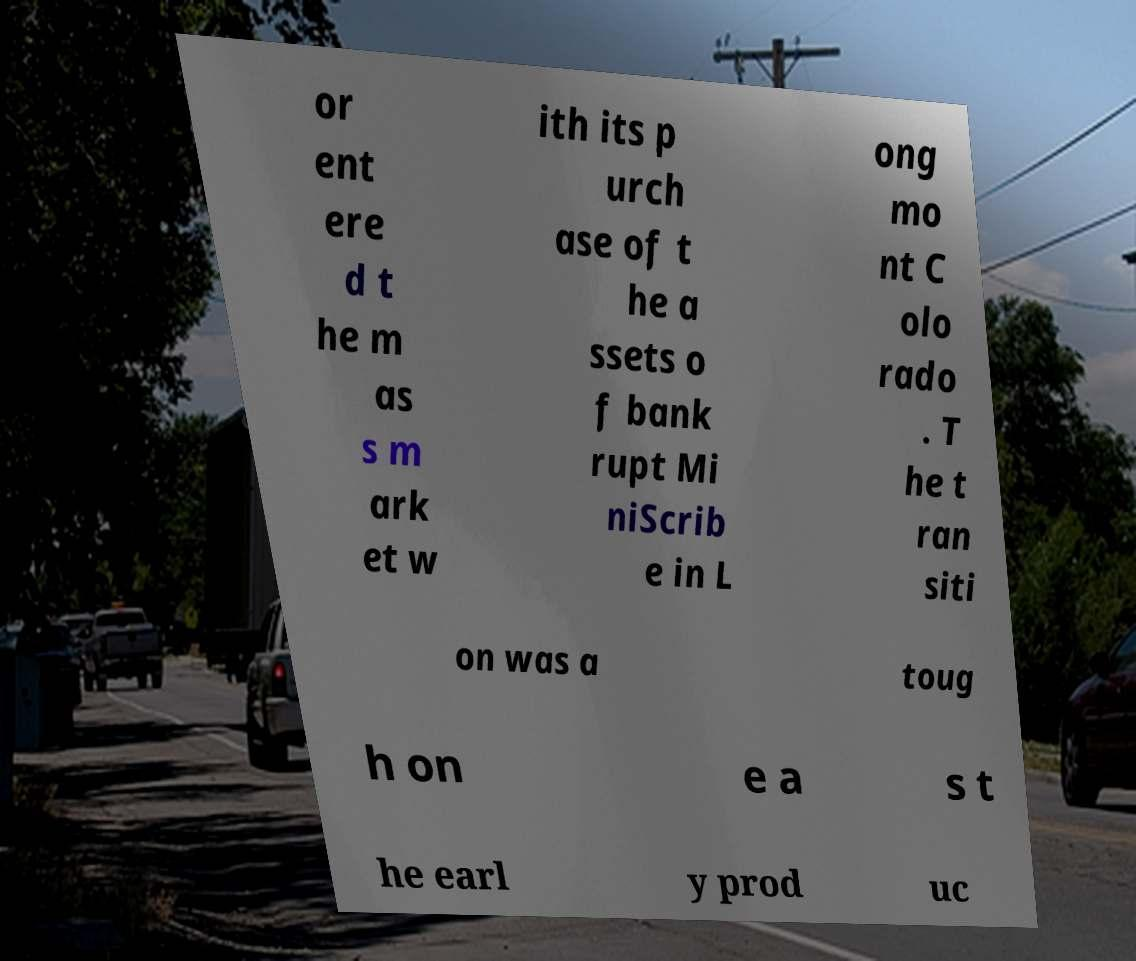Please identify and transcribe the text found in this image. or ent ere d t he m as s m ark et w ith its p urch ase of t he a ssets o f bank rupt Mi niScrib e in L ong mo nt C olo rado . T he t ran siti on was a toug h on e a s t he earl y prod uc 